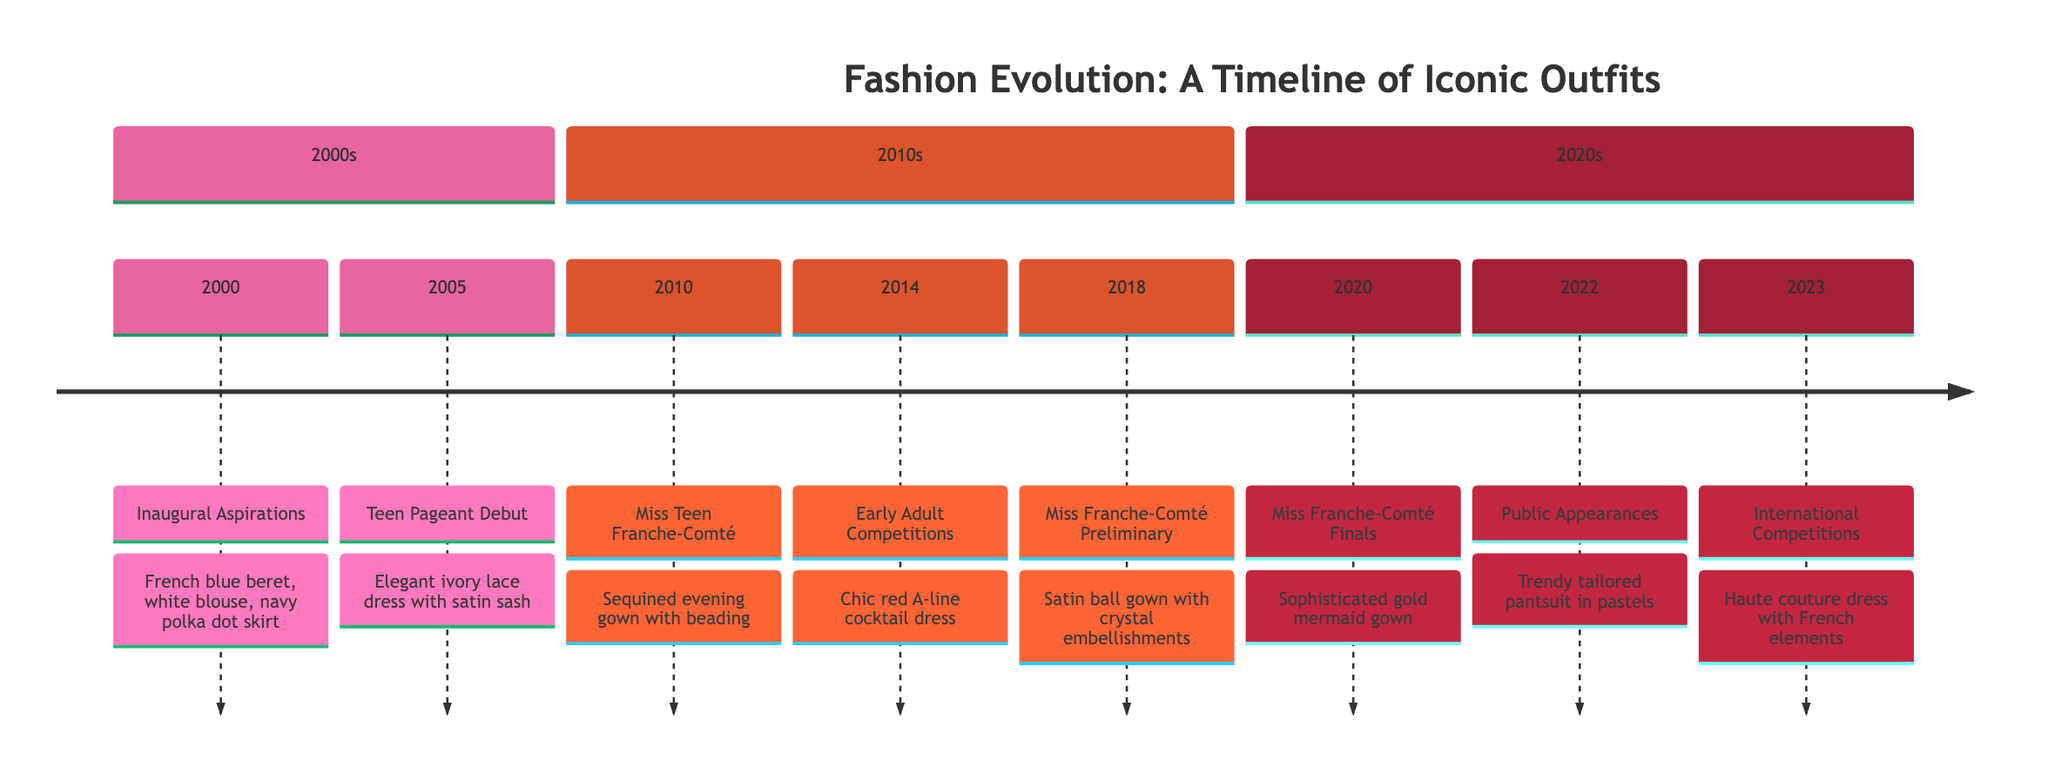What was the outfit for the event in 2020? The diagram lists the event for 2020 as "Miss Franche-Comté Finals," where the outfit worn was a "Sophisticated gold mermaid gown with embroidered details and a sleek silhouette." Therefore, the answer is directly derived from the information provided for that year.
Answer: Sophisticated gold mermaid gown How many events are listed in the timeline? The timeline features eight distinct entries from the year 2000 to 2023. Counting each entry, we find a total of eight events. This is a straightforward descriptive question focusing on the quantity of events presented.
Answer: 8 What type of dress was worn in the Miss Teen Franche-Comté in 2010? Referring to the entry for the year 2010, it states that a "Sequined evening gown with intricate beading and a deep V neckline" was the outfit worn during the Miss Teen Franche-Comté competition. The question specifically asks for the type of dress, which can be found in the description for that year.
Answer: Sequined evening gown Which outfit featured traditional French elements? The entry for the year 2023 indicates that the participant wore an "Exclusive haute couture dress featuring traditional French elements with contemporary design." This combines elements unique to the French fashion style, making it clear which outfit corresponds to the question asked.
Answer: Exclusive haute couture dress In what year was the trendy tailored pantsuit worn? According to the timeline, the "Trendy tailored pantsuit in pastel colors" was worn in 2022 during public appearances. This requires recalling the details associated with the specific year mentioned in the question.
Answer: 2022 What color is associated with the outfit worn in 2005? The timeline notes the outfit for the event in 2005 as an "Elegant ivory lace dress with a satin sash." Given that ivory is a shade of white and the question seeks the color associated with this outfit from that year, the straightforward answer reflects that.
Answer: Ivory Which event had the outfit with crystal embellishments? The event for 2018 states the outfit was a "Graceful satin ball gown with an extended train and crystal embellishments." Thus, connecting the description with the question specifies that the gown with crystal embellishments was worn during the Miss Franche-Comté Preliminary Rounds.
Answer: Miss Franche-Comté Preliminary Rounds What outfit was worn at the local teen beauty pageant in 2005? The timeline identifies this event as featuring an "Elegant ivory lace dress with a satin sash." By directly connecting this description to the corresponding event in 2005, we can accurately answer the question based on the outlined details.
Answer: Elegant ivory lace dress 